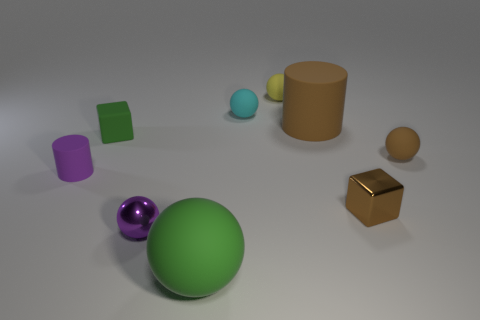Subtract all yellow cylinders. Subtract all red cubes. How many cylinders are left? 2 Subtract all red spheres. How many yellow cubes are left? 0 Add 2 grays. How many small greens exist? 0 Subtract all brown cylinders. Subtract all tiny green matte blocks. How many objects are left? 7 Add 6 cyan matte spheres. How many cyan matte spheres are left? 7 Add 4 big purple spheres. How many big purple spheres exist? 4 Add 1 tiny rubber blocks. How many objects exist? 10 Subtract all brown cubes. How many cubes are left? 1 Subtract all large matte balls. How many balls are left? 4 Subtract 0 cyan blocks. How many objects are left? 9 